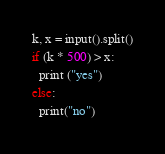Convert code to text. <code><loc_0><loc_0><loc_500><loc_500><_Python_>k, x = input().split()
if (k * 500) > x:
  print ("yes")
else:
  print("no")</code> 